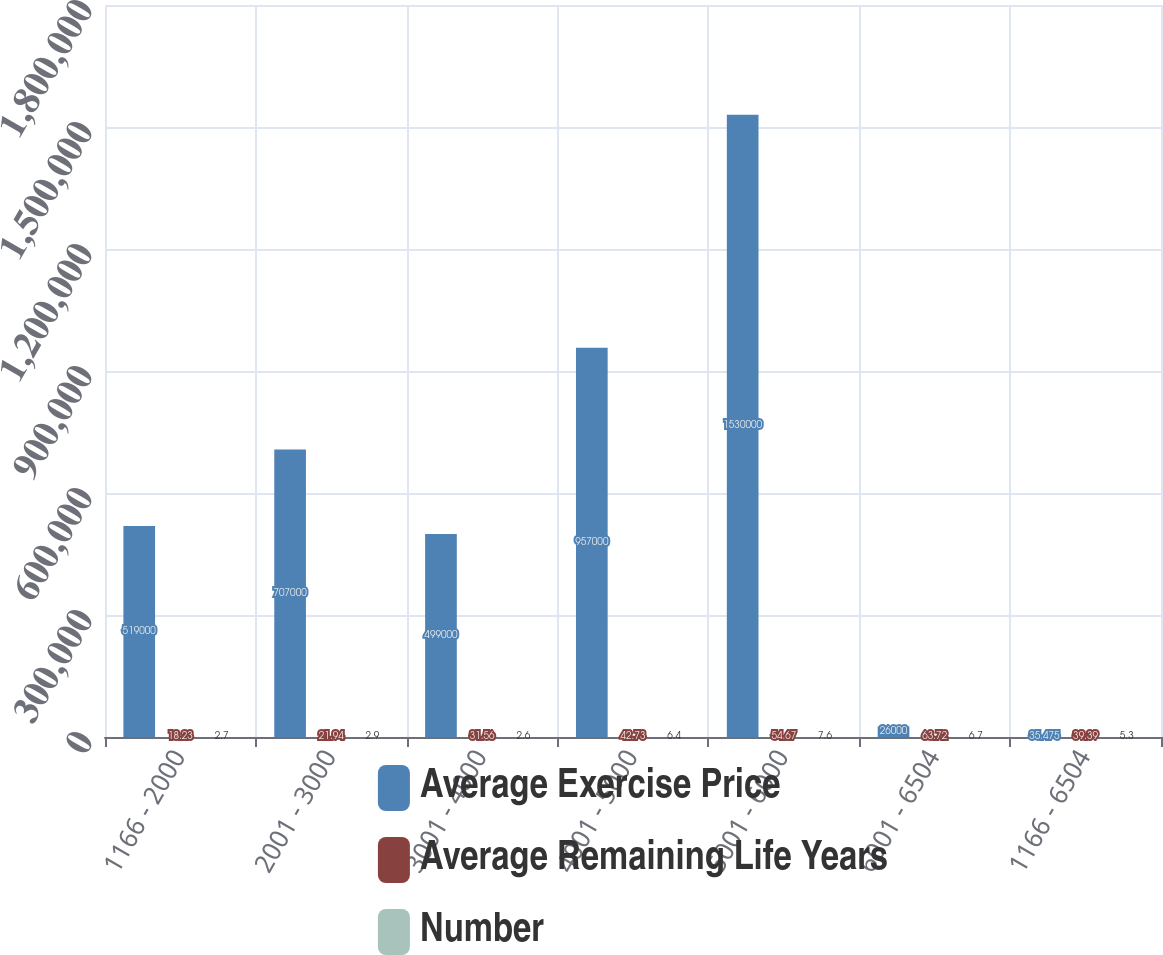<chart> <loc_0><loc_0><loc_500><loc_500><stacked_bar_chart><ecel><fcel>1166 - 2000<fcel>2001 - 3000<fcel>3001 - 4000<fcel>4001 - 5000<fcel>5001 - 6000<fcel>6001 - 6504<fcel>1166 - 6504<nl><fcel>Average Exercise Price<fcel>519000<fcel>707000<fcel>499000<fcel>957000<fcel>1.53e+06<fcel>26000<fcel>35.475<nl><fcel>Average Remaining Life Years<fcel>18.23<fcel>21.94<fcel>31.56<fcel>42.73<fcel>54.67<fcel>63.72<fcel>39.39<nl><fcel>Number<fcel>2.7<fcel>2.9<fcel>2.6<fcel>6.4<fcel>7.6<fcel>6.7<fcel>5.3<nl></chart> 